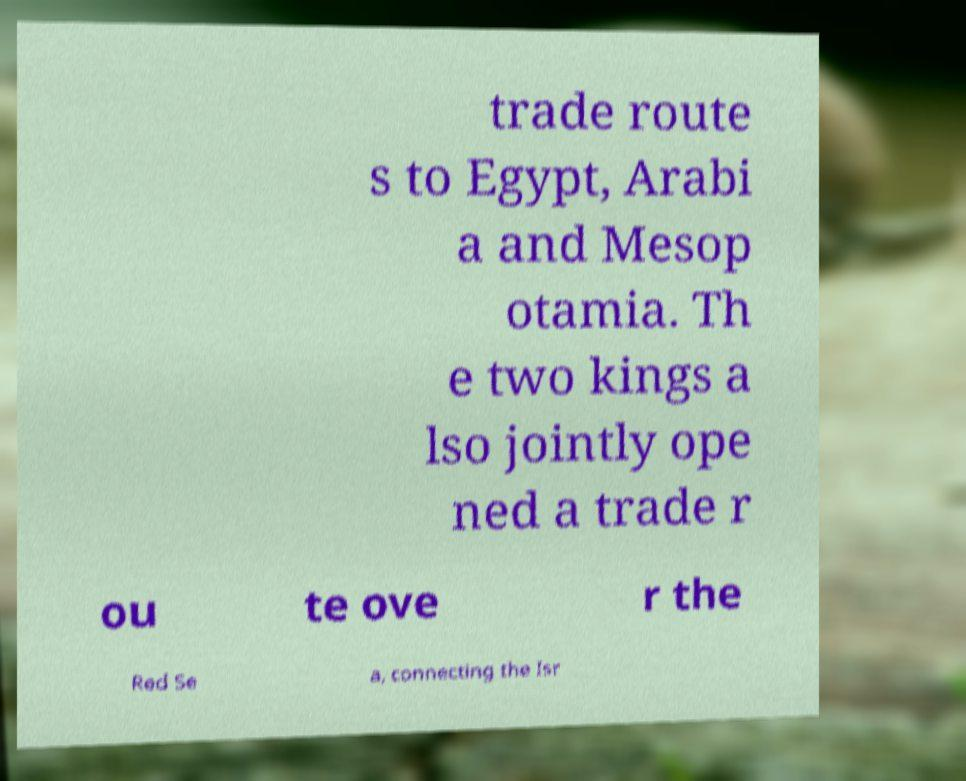Can you read and provide the text displayed in the image?This photo seems to have some interesting text. Can you extract and type it out for me? trade route s to Egypt, Arabi a and Mesop otamia. Th e two kings a lso jointly ope ned a trade r ou te ove r the Red Se a, connecting the Isr 